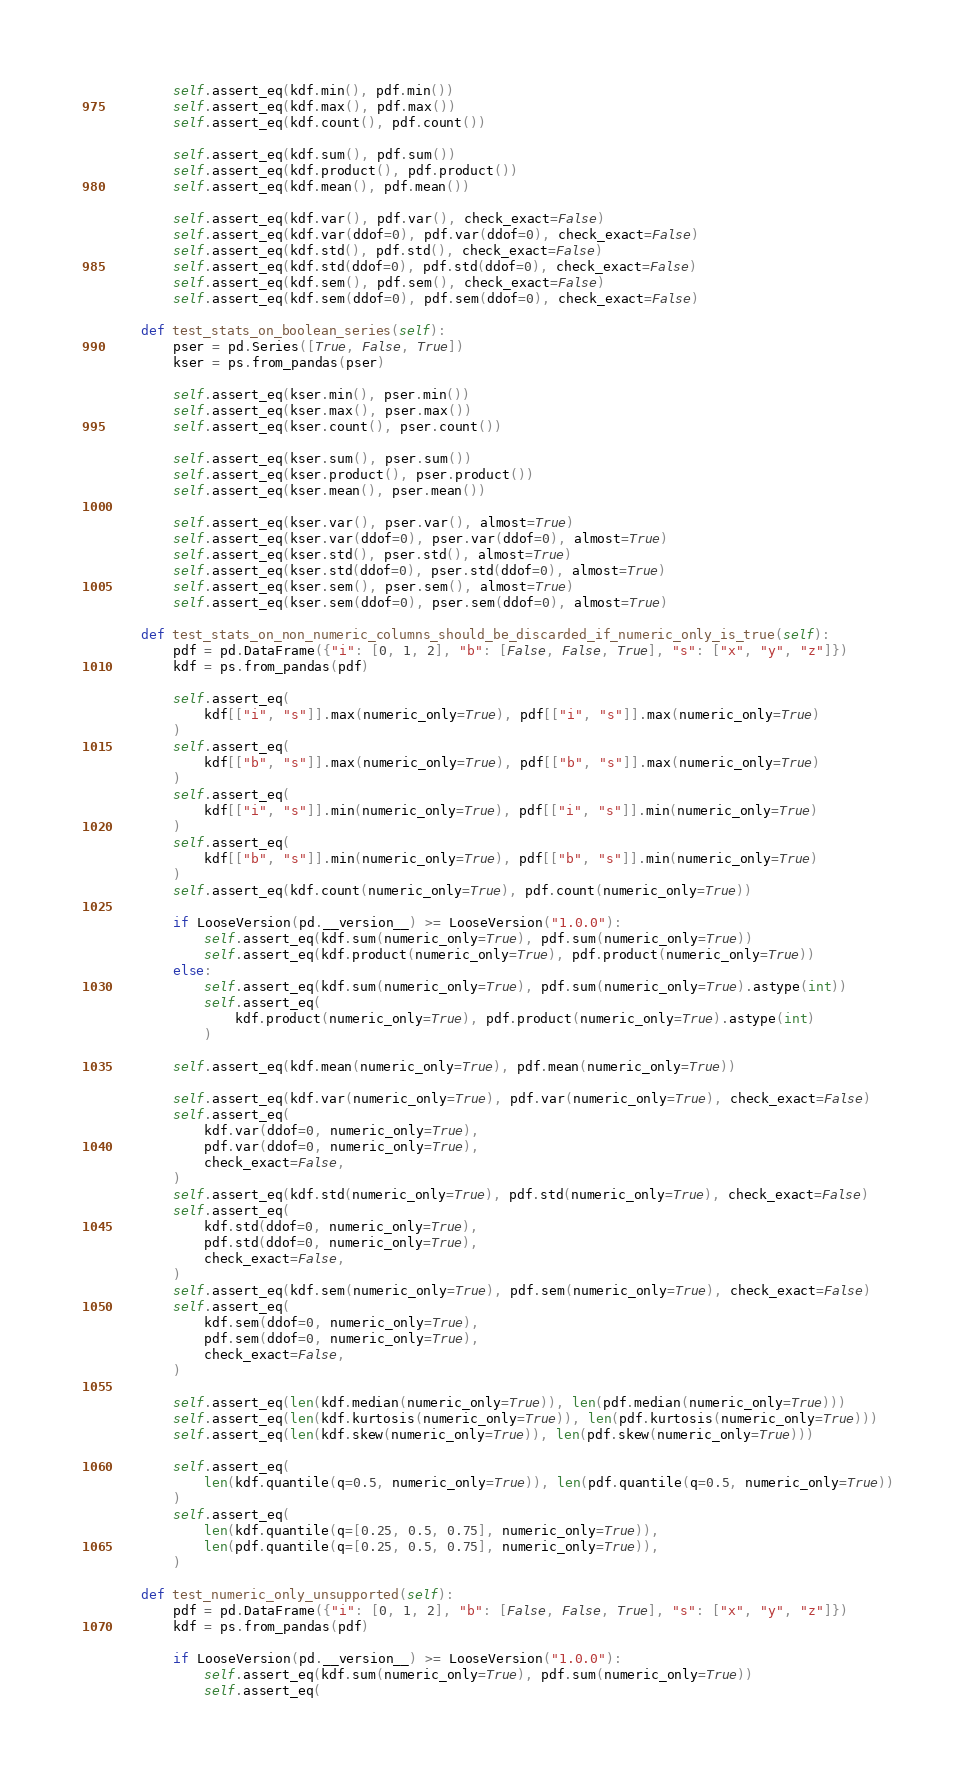Convert code to text. <code><loc_0><loc_0><loc_500><loc_500><_Python_>        self.assert_eq(kdf.min(), pdf.min())
        self.assert_eq(kdf.max(), pdf.max())
        self.assert_eq(kdf.count(), pdf.count())

        self.assert_eq(kdf.sum(), pdf.sum())
        self.assert_eq(kdf.product(), pdf.product())
        self.assert_eq(kdf.mean(), pdf.mean())

        self.assert_eq(kdf.var(), pdf.var(), check_exact=False)
        self.assert_eq(kdf.var(ddof=0), pdf.var(ddof=0), check_exact=False)
        self.assert_eq(kdf.std(), pdf.std(), check_exact=False)
        self.assert_eq(kdf.std(ddof=0), pdf.std(ddof=0), check_exact=False)
        self.assert_eq(kdf.sem(), pdf.sem(), check_exact=False)
        self.assert_eq(kdf.sem(ddof=0), pdf.sem(ddof=0), check_exact=False)

    def test_stats_on_boolean_series(self):
        pser = pd.Series([True, False, True])
        kser = ps.from_pandas(pser)

        self.assert_eq(kser.min(), pser.min())
        self.assert_eq(kser.max(), pser.max())
        self.assert_eq(kser.count(), pser.count())

        self.assert_eq(kser.sum(), pser.sum())
        self.assert_eq(kser.product(), pser.product())
        self.assert_eq(kser.mean(), pser.mean())

        self.assert_eq(kser.var(), pser.var(), almost=True)
        self.assert_eq(kser.var(ddof=0), pser.var(ddof=0), almost=True)
        self.assert_eq(kser.std(), pser.std(), almost=True)
        self.assert_eq(kser.std(ddof=0), pser.std(ddof=0), almost=True)
        self.assert_eq(kser.sem(), pser.sem(), almost=True)
        self.assert_eq(kser.sem(ddof=0), pser.sem(ddof=0), almost=True)

    def test_stats_on_non_numeric_columns_should_be_discarded_if_numeric_only_is_true(self):
        pdf = pd.DataFrame({"i": [0, 1, 2], "b": [False, False, True], "s": ["x", "y", "z"]})
        kdf = ps.from_pandas(pdf)

        self.assert_eq(
            kdf[["i", "s"]].max(numeric_only=True), pdf[["i", "s"]].max(numeric_only=True)
        )
        self.assert_eq(
            kdf[["b", "s"]].max(numeric_only=True), pdf[["b", "s"]].max(numeric_only=True)
        )
        self.assert_eq(
            kdf[["i", "s"]].min(numeric_only=True), pdf[["i", "s"]].min(numeric_only=True)
        )
        self.assert_eq(
            kdf[["b", "s"]].min(numeric_only=True), pdf[["b", "s"]].min(numeric_only=True)
        )
        self.assert_eq(kdf.count(numeric_only=True), pdf.count(numeric_only=True))

        if LooseVersion(pd.__version__) >= LooseVersion("1.0.0"):
            self.assert_eq(kdf.sum(numeric_only=True), pdf.sum(numeric_only=True))
            self.assert_eq(kdf.product(numeric_only=True), pdf.product(numeric_only=True))
        else:
            self.assert_eq(kdf.sum(numeric_only=True), pdf.sum(numeric_only=True).astype(int))
            self.assert_eq(
                kdf.product(numeric_only=True), pdf.product(numeric_only=True).astype(int)
            )

        self.assert_eq(kdf.mean(numeric_only=True), pdf.mean(numeric_only=True))

        self.assert_eq(kdf.var(numeric_only=True), pdf.var(numeric_only=True), check_exact=False)
        self.assert_eq(
            kdf.var(ddof=0, numeric_only=True),
            pdf.var(ddof=0, numeric_only=True),
            check_exact=False,
        )
        self.assert_eq(kdf.std(numeric_only=True), pdf.std(numeric_only=True), check_exact=False)
        self.assert_eq(
            kdf.std(ddof=0, numeric_only=True),
            pdf.std(ddof=0, numeric_only=True),
            check_exact=False,
        )
        self.assert_eq(kdf.sem(numeric_only=True), pdf.sem(numeric_only=True), check_exact=False)
        self.assert_eq(
            kdf.sem(ddof=0, numeric_only=True),
            pdf.sem(ddof=0, numeric_only=True),
            check_exact=False,
        )

        self.assert_eq(len(kdf.median(numeric_only=True)), len(pdf.median(numeric_only=True)))
        self.assert_eq(len(kdf.kurtosis(numeric_only=True)), len(pdf.kurtosis(numeric_only=True)))
        self.assert_eq(len(kdf.skew(numeric_only=True)), len(pdf.skew(numeric_only=True)))

        self.assert_eq(
            len(kdf.quantile(q=0.5, numeric_only=True)), len(pdf.quantile(q=0.5, numeric_only=True))
        )
        self.assert_eq(
            len(kdf.quantile(q=[0.25, 0.5, 0.75], numeric_only=True)),
            len(pdf.quantile(q=[0.25, 0.5, 0.75], numeric_only=True)),
        )

    def test_numeric_only_unsupported(self):
        pdf = pd.DataFrame({"i": [0, 1, 2], "b": [False, False, True], "s": ["x", "y", "z"]})
        kdf = ps.from_pandas(pdf)

        if LooseVersion(pd.__version__) >= LooseVersion("1.0.0"):
            self.assert_eq(kdf.sum(numeric_only=True), pdf.sum(numeric_only=True))
            self.assert_eq(</code> 